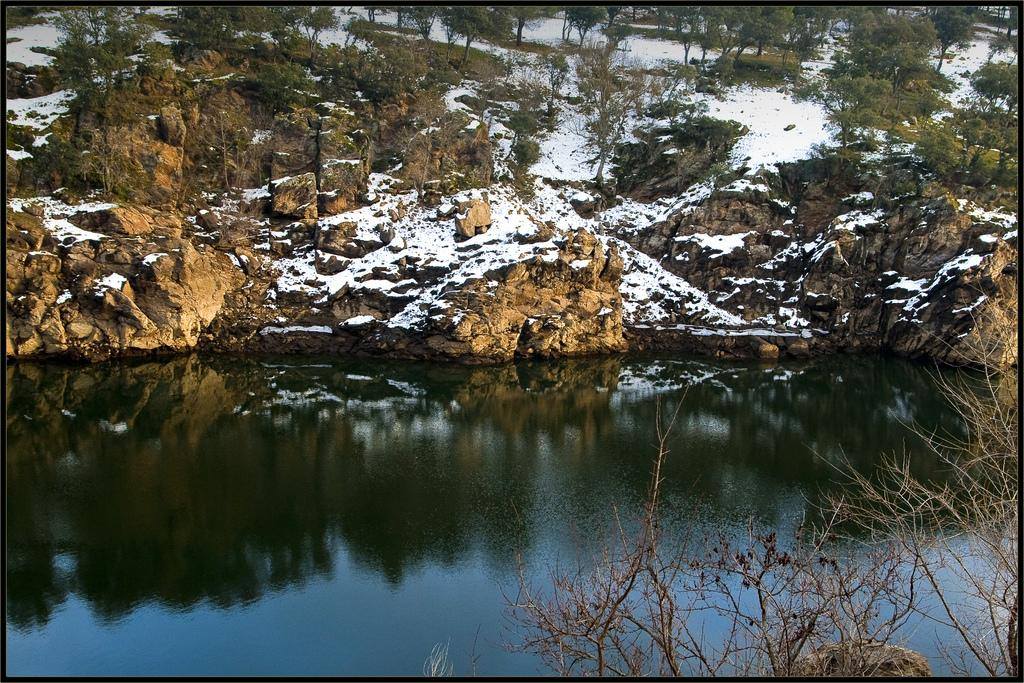What is the primary element visible in the image? There is water in the image. What can be seen near the water? There are many rocks and trees near the water. How is the weather in the image? Snow is visible on the rocks, indicating cold weather. Can you see a request being made in the image? There is no request being made in the image; it features water, rocks, trees, and snow. Is there an arm visible in the image? There is no arm visible in the image; it primarily shows natural elements like water, rocks, trees, and snow. 